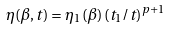<formula> <loc_0><loc_0><loc_500><loc_500>\eta ( \beta , t ) = \eta _ { 1 } ( \beta ) \, ( t _ { 1 } / t ) ^ { p + 1 }</formula> 